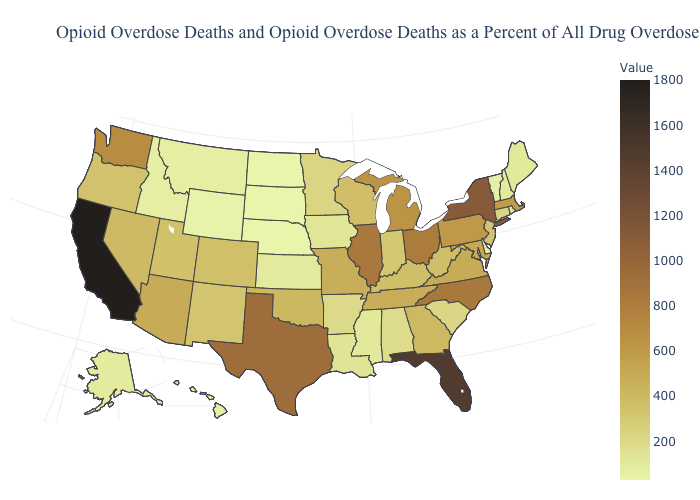Among the states that border Oklahoma , does Kansas have the lowest value?
Concise answer only. Yes. Among the states that border North Carolina , which have the highest value?
Quick response, please. Virginia. Which states have the lowest value in the Northeast?
Keep it brief. Vermont. Does Nebraska have the lowest value in the MidWest?
Keep it brief. Yes. Which states have the lowest value in the South?
Short answer required. Delaware. Which states have the highest value in the USA?
Answer briefly. California. Among the states that border Maryland , which have the highest value?
Short answer required. Pennsylvania. Does the map have missing data?
Short answer required. No. Among the states that border Montana , which have the highest value?
Quick response, please. Idaho. 